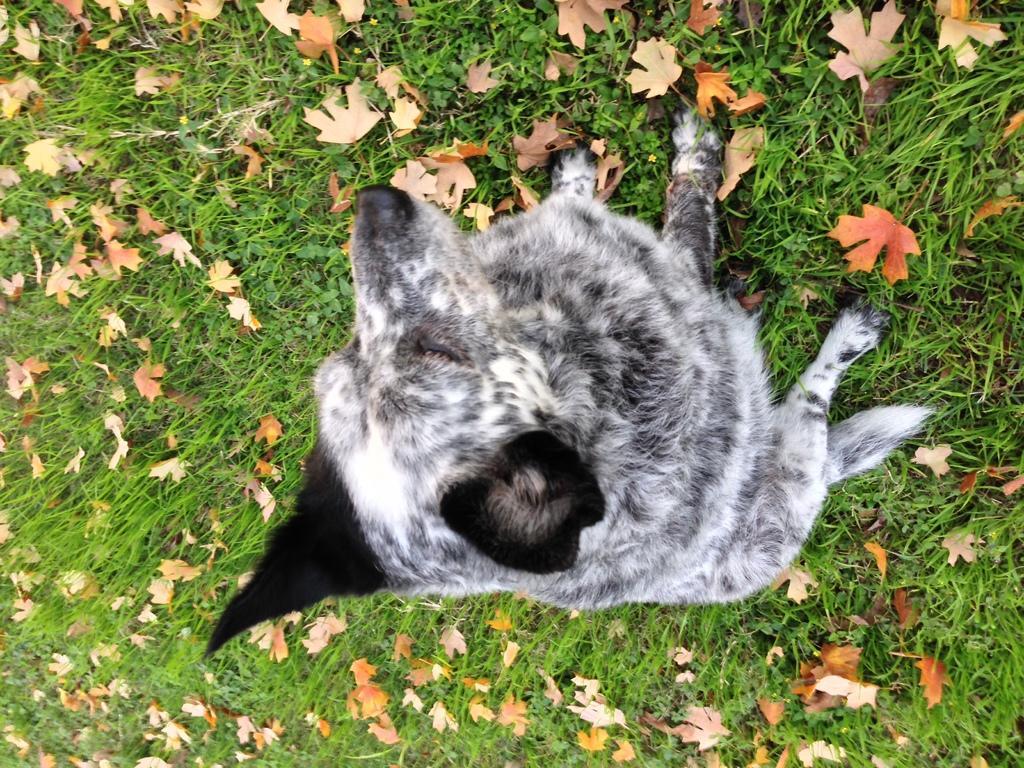Please provide a concise description of this image. This is a dog sitting. I can see the dried leaves lying on the grass. 